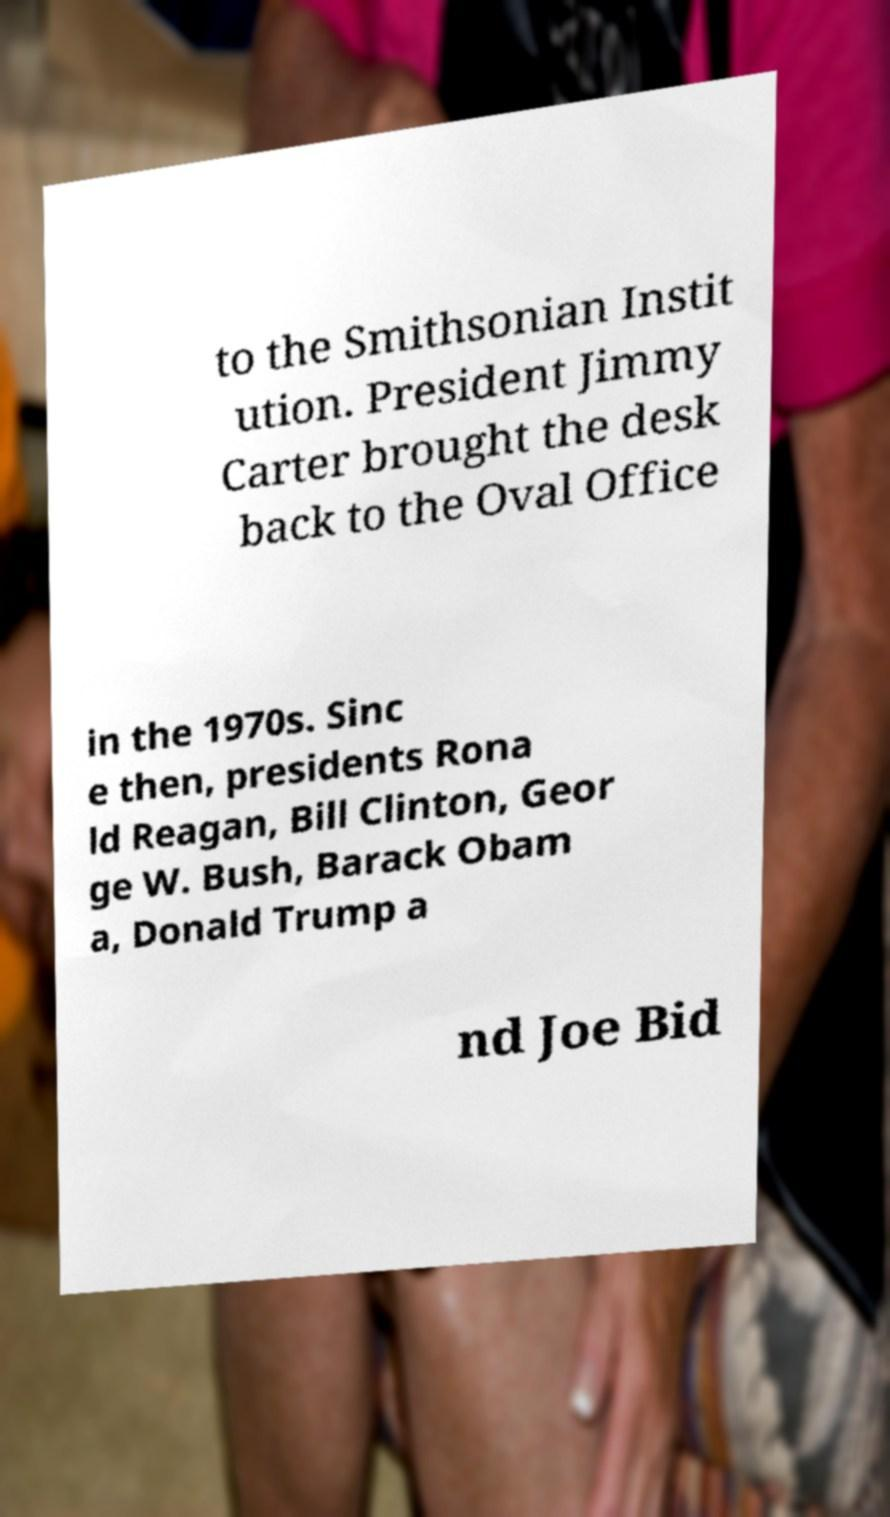Please identify and transcribe the text found in this image. to the Smithsonian Instit ution. President Jimmy Carter brought the desk back to the Oval Office in the 1970s. Sinc e then, presidents Rona ld Reagan, Bill Clinton, Geor ge W. Bush, Barack Obam a, Donald Trump a nd Joe Bid 